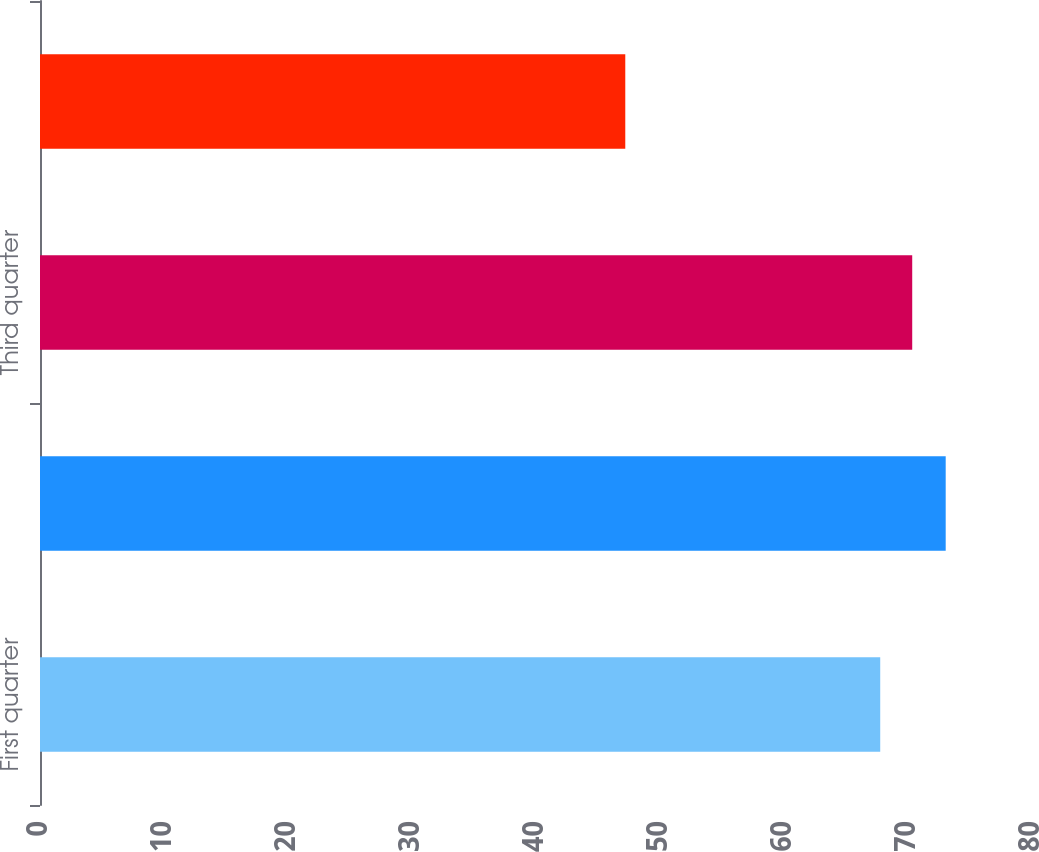Convert chart. <chart><loc_0><loc_0><loc_500><loc_500><bar_chart><fcel>First quarter<fcel>Second quarter<fcel>Third quarter<fcel>Fourth quarter<nl><fcel>67.76<fcel>73.04<fcel>70.34<fcel>47.2<nl></chart> 